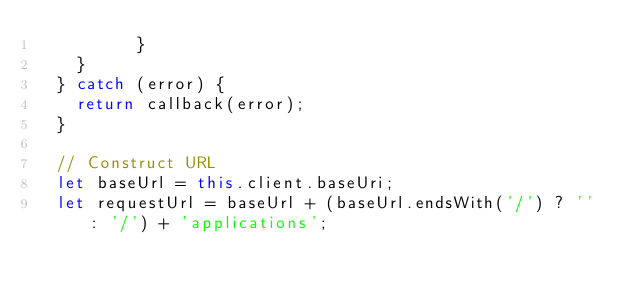Convert code to text. <code><loc_0><loc_0><loc_500><loc_500><_JavaScript_>          }
    }
  } catch (error) {
    return callback(error);
  }

  // Construct URL
  let baseUrl = this.client.baseUri;
  let requestUrl = baseUrl + (baseUrl.endsWith('/') ? '' : '/') + 'applications';</code> 